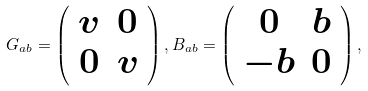Convert formula to latex. <formula><loc_0><loc_0><loc_500><loc_500>G _ { a b } = \left ( \begin{array} { c c } v & 0 \\ 0 & v \end{array} \right ) , B _ { a b } = \left ( \begin{array} { c c } 0 & b \\ - b & 0 \end{array} \right ) ,</formula> 